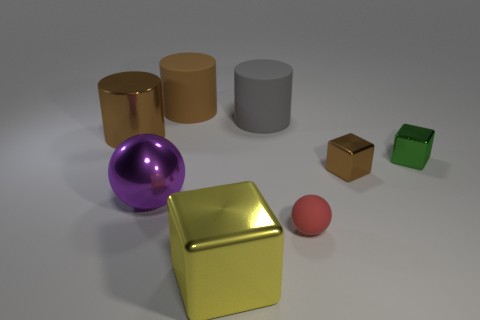What size is the cube behind the brown metallic object that is on the right side of the large shiny object in front of the red rubber sphere?
Provide a short and direct response. Small. There is a brown thing that is the same shape as the big yellow metal object; what size is it?
Provide a succinct answer. Small. What number of objects are left of the purple metallic object?
Keep it short and to the point. 1. Does the rubber cylinder that is to the left of the big gray cylinder have the same color as the metallic cylinder?
Your answer should be compact. Yes. How many yellow objects are either metal blocks or big rubber objects?
Provide a succinct answer. 1. The shiny object that is in front of the ball to the right of the large cube is what color?
Provide a short and direct response. Yellow. There is another big cylinder that is the same color as the metallic cylinder; what is it made of?
Provide a short and direct response. Rubber. There is a small block that is in front of the green metal thing; what is its color?
Provide a succinct answer. Brown. Does the metal cube that is to the left of the red rubber sphere have the same size as the green shiny thing?
Make the answer very short. No. There is a rubber cylinder that is the same color as the large shiny cylinder; what size is it?
Your answer should be very brief. Large. 